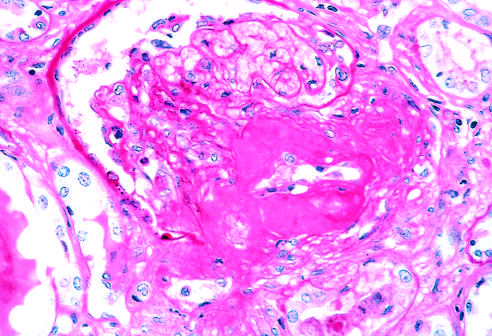s severe renal hyaline arteriolosclerosis in the periodic acid-schiff stain specimen?
Answer the question using a single word or phrase. Yes 